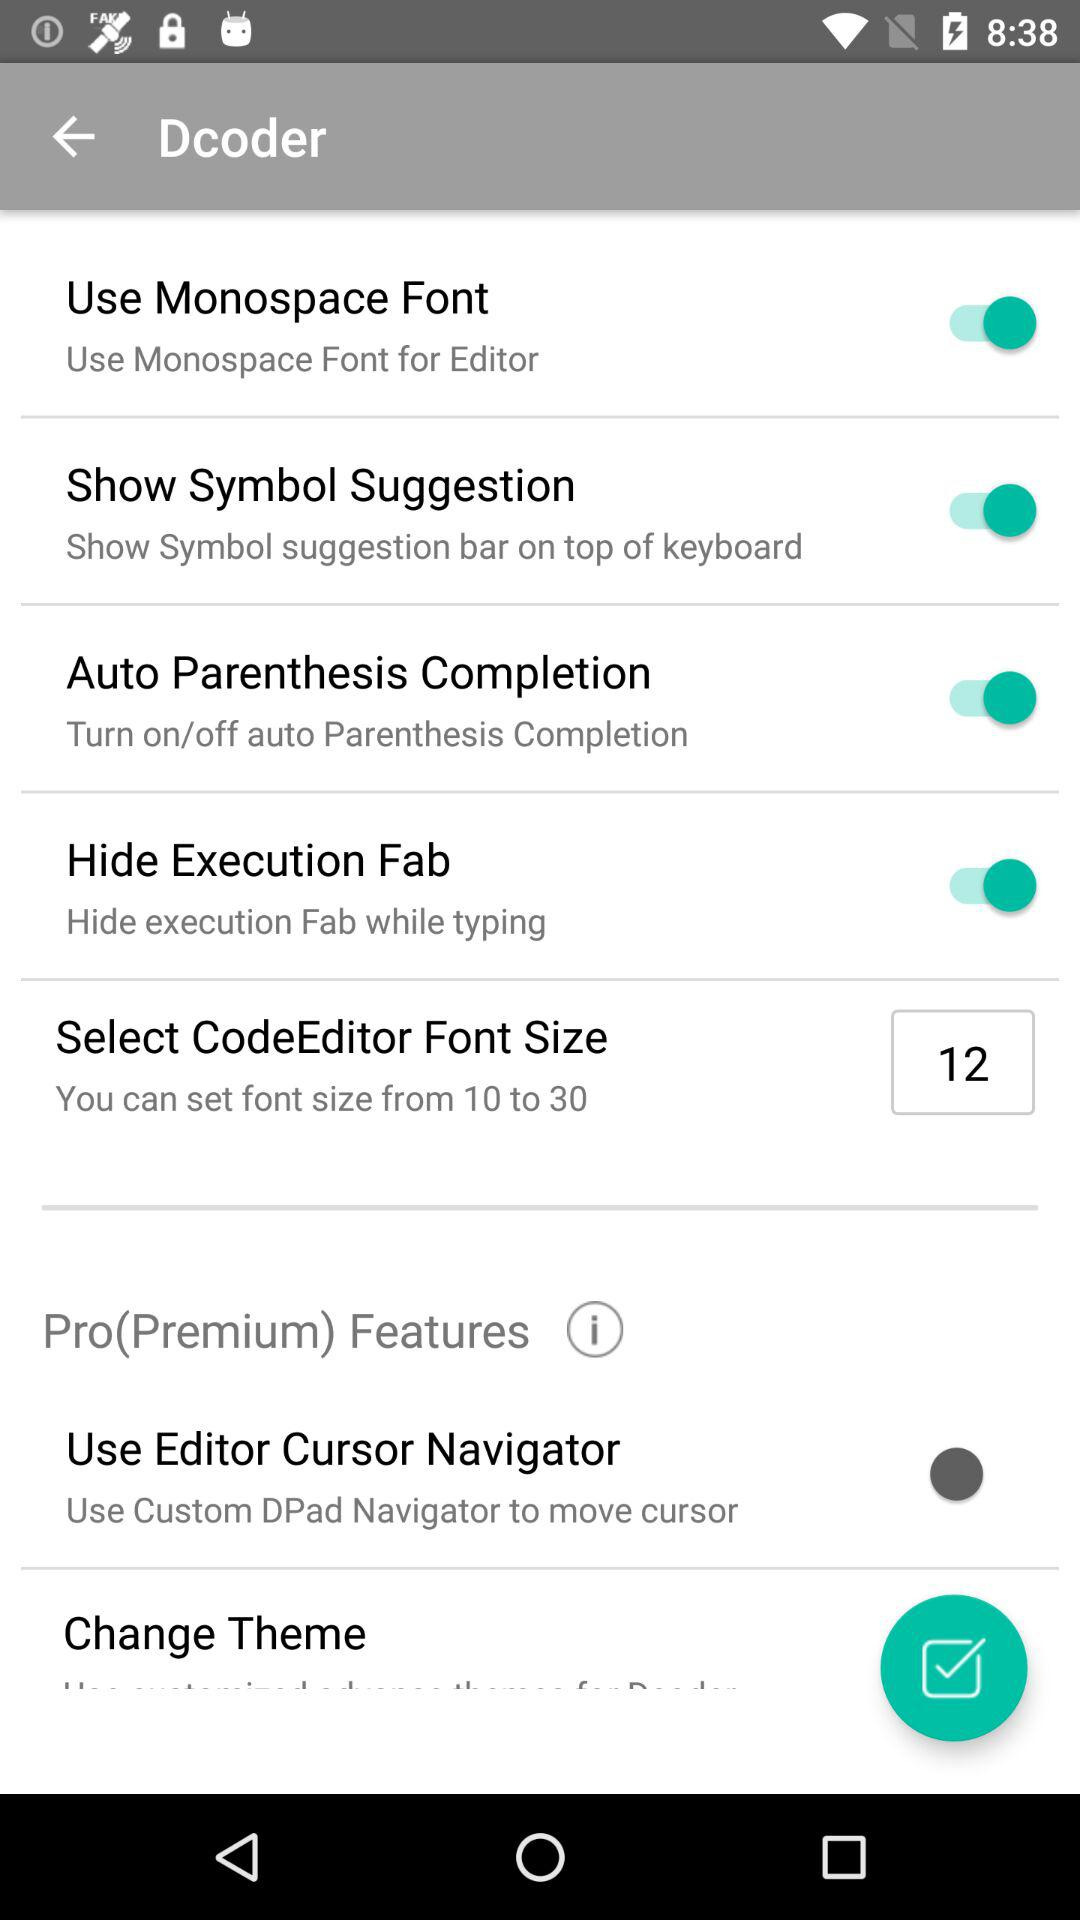What is the selected "CodeEditor" font size? The selected "CodeEditor" font size is 12. 